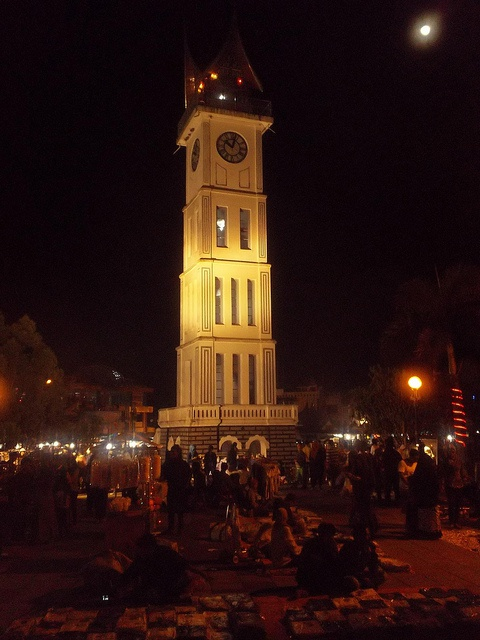Describe the objects in this image and their specific colors. I can see people in black, maroon, and brown tones, people in black, maroon, and brown tones, people in black, maroon, and olive tones, people in black, maroon, and gray tones, and people in black and maroon tones in this image. 